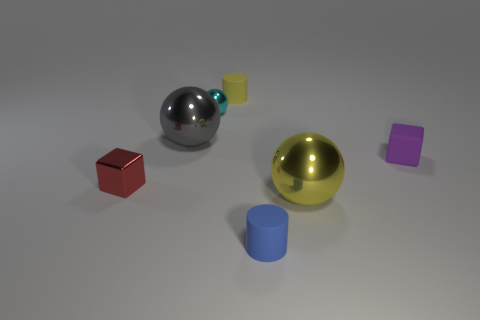Add 1 red blocks. How many objects exist? 8 Subtract all balls. How many objects are left? 4 Subtract all green cylinders. Subtract all tiny cyan shiny balls. How many objects are left? 6 Add 7 metal cubes. How many metal cubes are left? 8 Add 4 tiny green shiny objects. How many tiny green shiny objects exist? 4 Subtract 0 gray blocks. How many objects are left? 7 